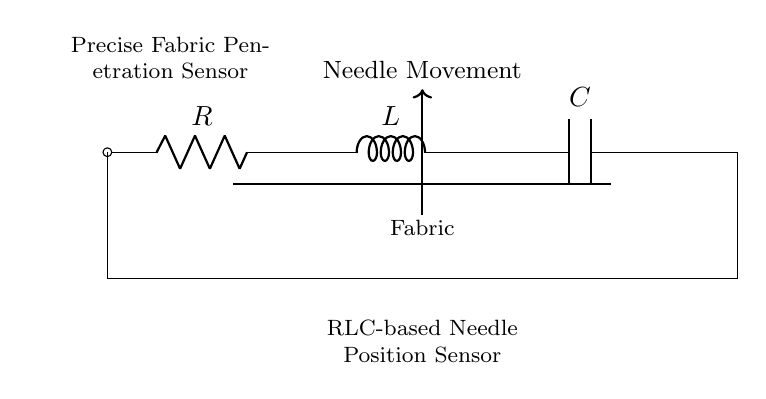What are the components of this circuit? The circuit diagram includes a resistor, an inductor, and a capacitor. These are standard components represented in the circuit diagram.
Answer: Resistor, Inductor, Capacitor What does the inductor indicate in this circuit? The inductor in this circuit serves to store energy in a magnetic field and control the changes in current flow, which is important for sensing needle position.
Answer: Energy storage What is the overall purpose of this RLC circuit? The RLC circuit is designed to serve as a needle position sensor, providing precise fabric penetration control by monitoring the fabric interaction.
Answer: Needle position sensor How does the resistor affect the circuit functionality? The resistor limits the current flow within the circuit, ensuring that the inductor and capacitor operate effectively without drawing excessive current, which could damage the components.
Answer: Current limitation What type of response can this circuit provide regarding needle movement? This RLC circuit can provide oscillatory responses, which allow for precise detection of needle movement and position by analyzing the changes in current and voltage across the components.
Answer: Oscillatory response 